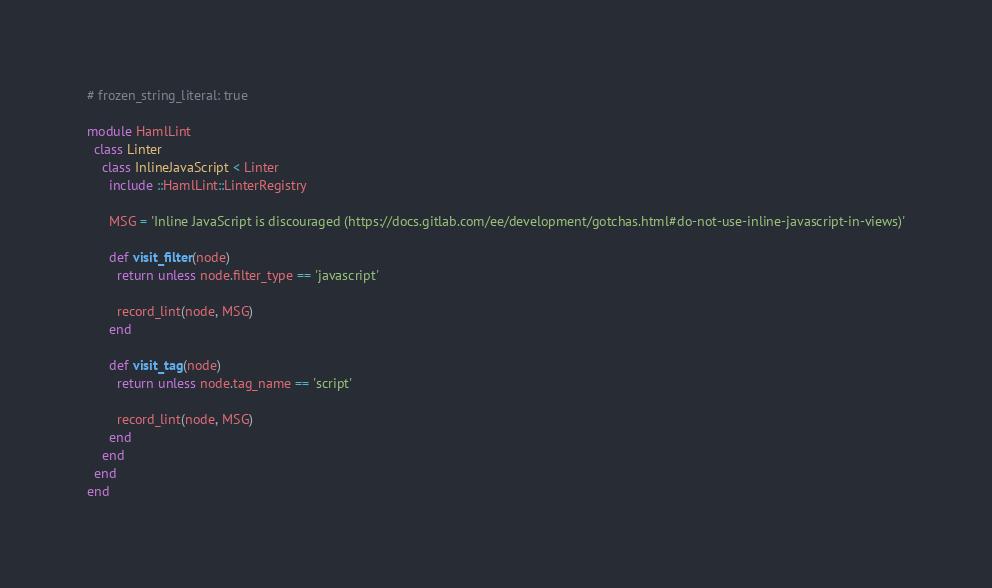<code> <loc_0><loc_0><loc_500><loc_500><_Ruby_># frozen_string_literal: true

module HamlLint
  class Linter
    class InlineJavaScript < Linter
      include ::HamlLint::LinterRegistry

      MSG = 'Inline JavaScript is discouraged (https://docs.gitlab.com/ee/development/gotchas.html#do-not-use-inline-javascript-in-views)'

      def visit_filter(node)
        return unless node.filter_type == 'javascript'

        record_lint(node, MSG)
      end

      def visit_tag(node)
        return unless node.tag_name == 'script'

        record_lint(node, MSG)
      end
    end
  end
end
</code> 